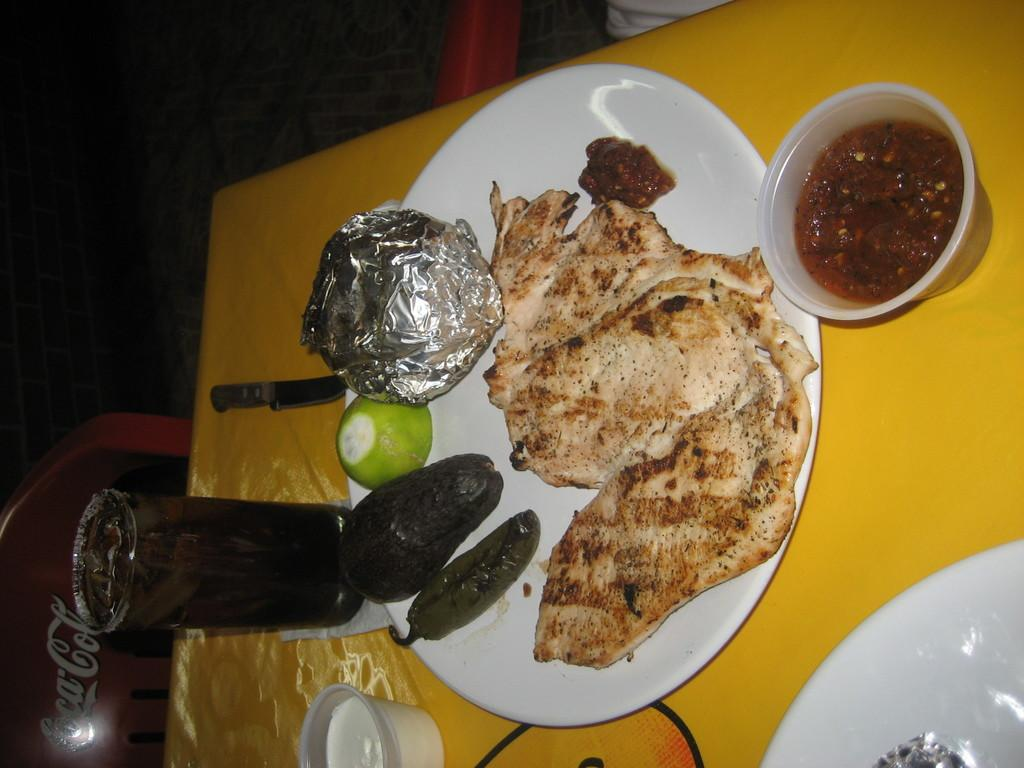What type of furniture is present in the image? There is a table and a chair in the image. How many plates are on the table? There are two plates on the table. What other items can be seen on the table? There is a glass, a knife, and two cups on the table. Is there any food visible in the image? Yes, there is food in one of the plates. How does the sand contribute to the meal in the image? There is no sand present in the image, so it does not contribute to the meal. 